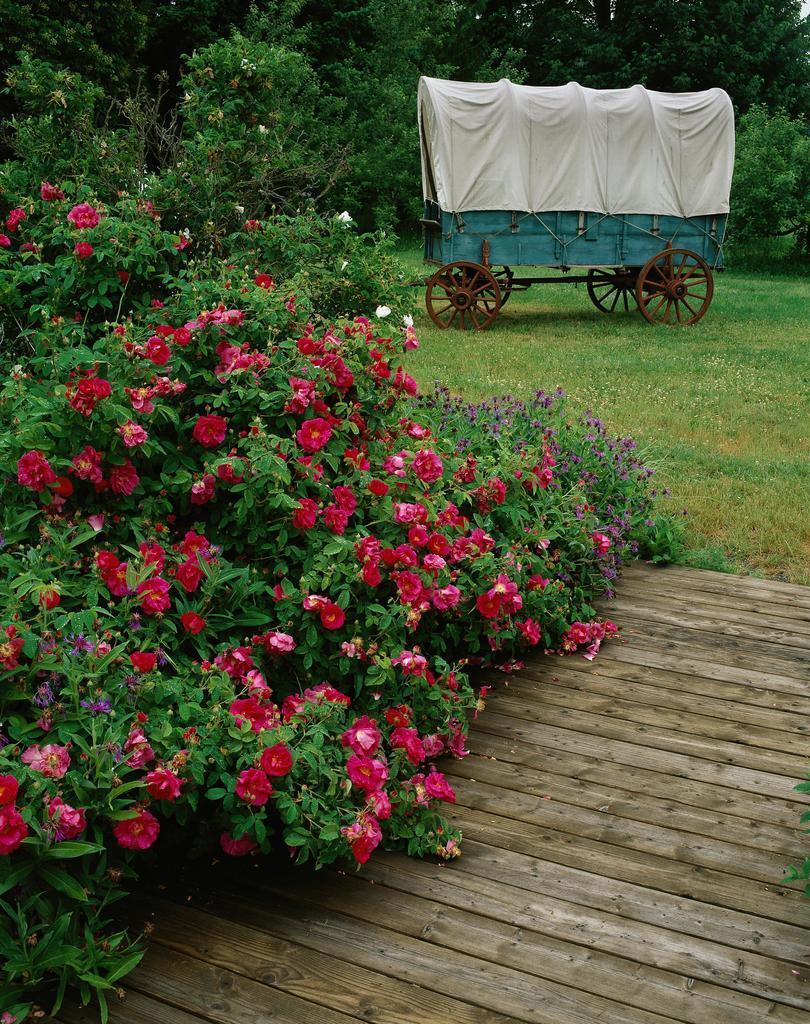In one or two sentences, can you explain what this image depicts? In this image there is a wooden path, on the left side there are rose plants, in the background there is cart and trees. 